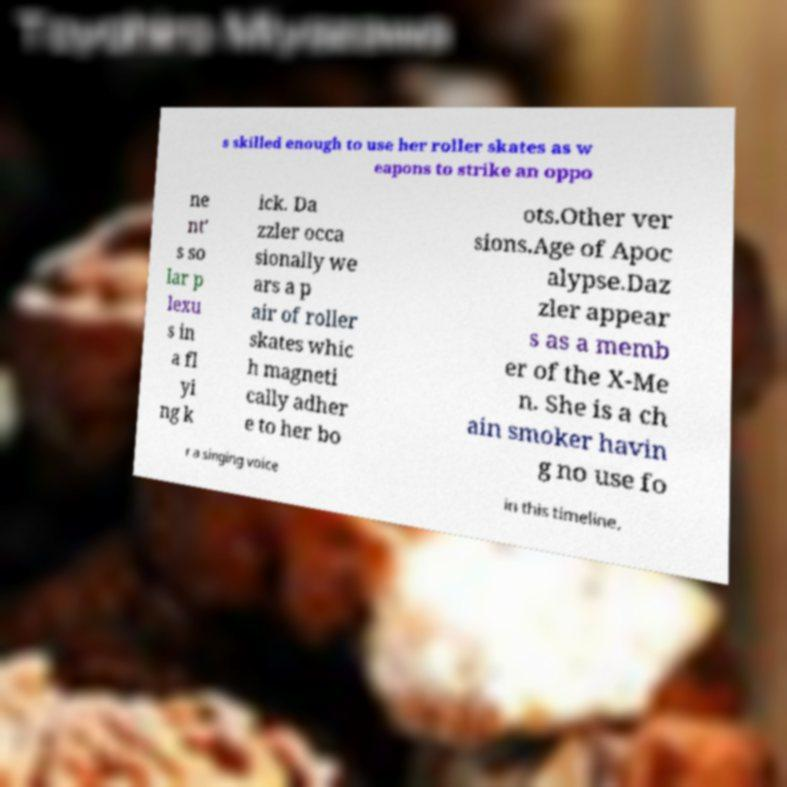There's text embedded in this image that I need extracted. Can you transcribe it verbatim? s skilled enough to use her roller skates as w eapons to strike an oppo ne nt' s so lar p lexu s in a fl yi ng k ick. Da zzler occa sionally we ars a p air of roller skates whic h magneti cally adher e to her bo ots.Other ver sions.Age of Apoc alypse.Daz zler appear s as a memb er of the X-Me n. She is a ch ain smoker havin g no use fo r a singing voice in this timeline. 